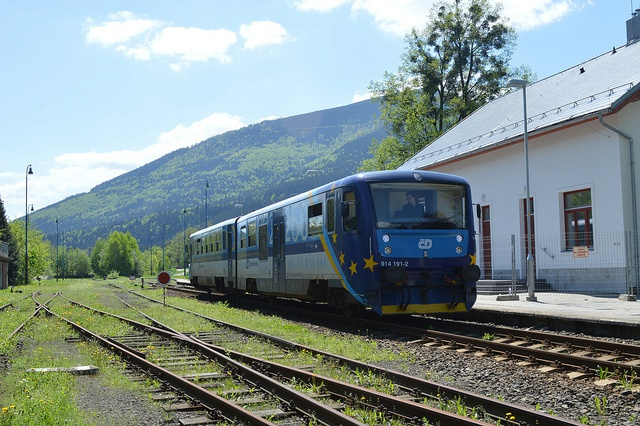Describe the objects in this image and their specific colors. I can see train in lightblue, black, navy, gray, and blue tones and people in lightblue, navy, gray, darkblue, and black tones in this image. 